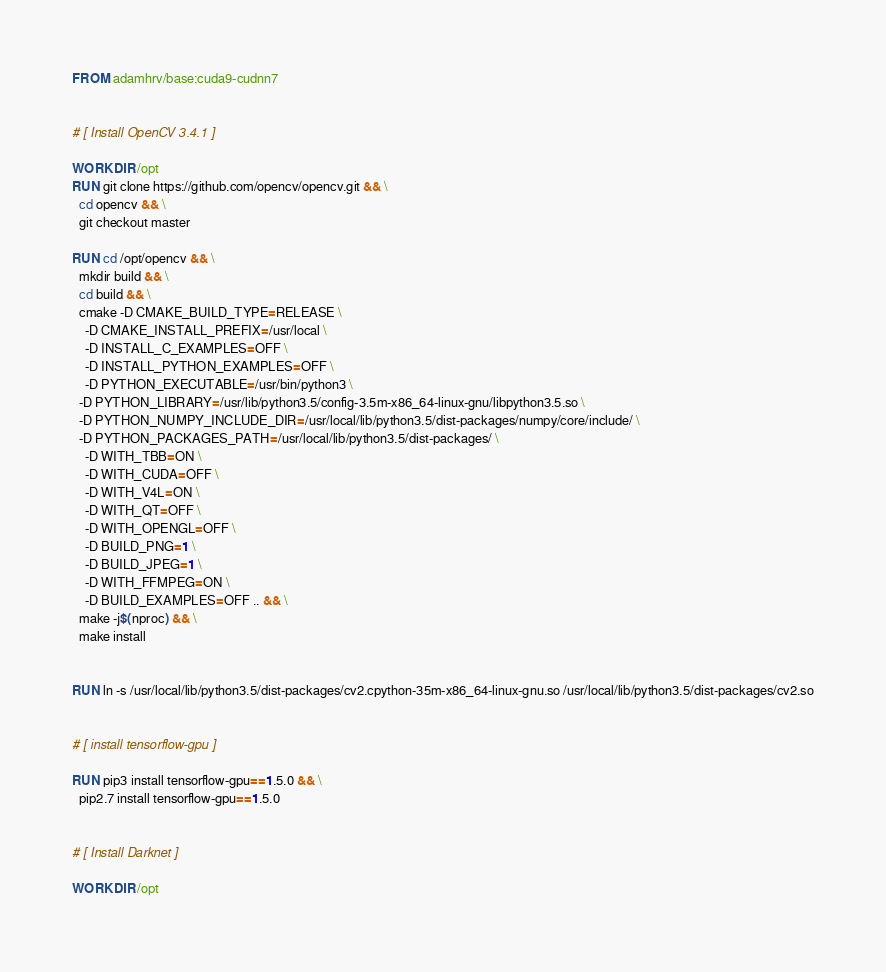<code> <loc_0><loc_0><loc_500><loc_500><_Dockerfile_>FROM adamhrv/base:cuda9-cudnn7


# [ Install OpenCV 3.4.1 ]

WORKDIR /opt
RUN git clone https://github.com/opencv/opencv.git && \
  cd opencv && \
  git checkout master

RUN cd /opt/opencv && \
  mkdir build && \
  cd build && \
  cmake -D CMAKE_BUILD_TYPE=RELEASE \
    -D CMAKE_INSTALL_PREFIX=/usr/local \
    -D INSTALL_C_EXAMPLES=OFF \
    -D INSTALL_PYTHON_EXAMPLES=OFF \
    -D PYTHON_EXECUTABLE=/usr/bin/python3 \
  -D PYTHON_LIBRARY=/usr/lib/python3.5/config-3.5m-x86_64-linux-gnu/libpython3.5.so \
  -D PYTHON_NUMPY_INCLUDE_DIR=/usr/local/lib/python3.5/dist-packages/numpy/core/include/ \
  -D PYTHON_PACKAGES_PATH=/usr/local/lib/python3.5/dist-packages/ \
    -D WITH_TBB=ON \
    -D WITH_CUDA=OFF \
    -D WITH_V4L=ON \
    -D WITH_QT=OFF \
    -D WITH_OPENGL=OFF \
    -D BUILD_PNG=1 \
    -D BUILD_JPEG=1 \
    -D WITH_FFMPEG=ON \
    -D BUILD_EXAMPLES=OFF .. && \
  make -j$(nproc) && \
  make install


RUN ln -s /usr/local/lib/python3.5/dist-packages/cv2.cpython-35m-x86_64-linux-gnu.so /usr/local/lib/python3.5/dist-packages/cv2.so


# [ install tensorflow-gpu ]

RUN pip3 install tensorflow-gpu==1.5.0 && \
  pip2.7 install tensorflow-gpu==1.5.0


# [ Install Darknet ]

WORKDIR /opt</code> 